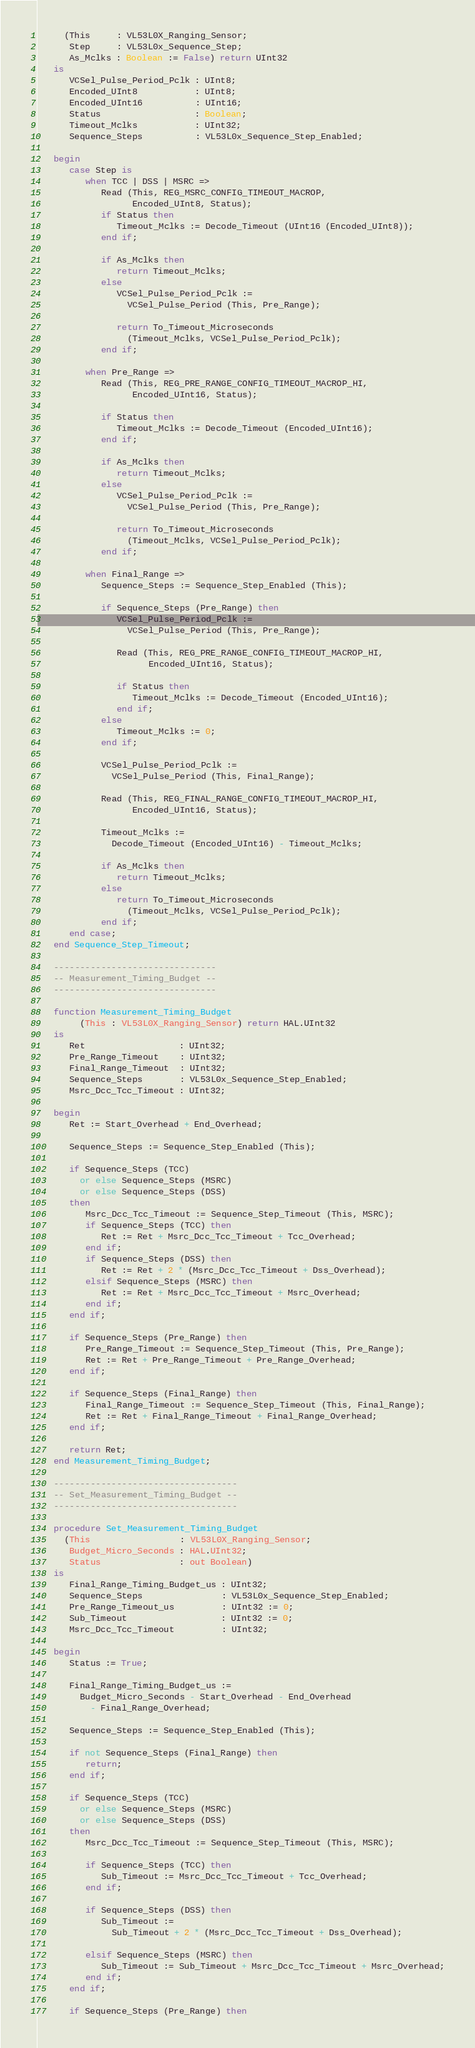<code> <loc_0><loc_0><loc_500><loc_500><_Ada_>     (This     : VL53L0X_Ranging_Sensor;
      Step     : VL53L0x_Sequence_Step;
      As_Mclks : Boolean := False) return UInt32
   is
      VCSel_Pulse_Period_Pclk : UInt8;
      Encoded_UInt8           : UInt8;
      Encoded_UInt16          : UInt16;
      Status                  : Boolean;
      Timeout_Mclks           : UInt32;
      Sequence_Steps          : VL53L0x_Sequence_Step_Enabled;

   begin
      case Step is
         when TCC | DSS | MSRC =>
            Read (This, REG_MSRC_CONFIG_TIMEOUT_MACROP,
                  Encoded_UInt8, Status);
            if Status then
               Timeout_Mclks := Decode_Timeout (UInt16 (Encoded_UInt8));
            end if;

            if As_Mclks then
               return Timeout_Mclks;
            else
               VCSel_Pulse_Period_Pclk :=
                 VCSel_Pulse_Period (This, Pre_Range);

               return To_Timeout_Microseconds
                 (Timeout_Mclks, VCSel_Pulse_Period_Pclk);
            end if;

         when Pre_Range =>
            Read (This, REG_PRE_RANGE_CONFIG_TIMEOUT_MACROP_HI,
                  Encoded_UInt16, Status);

            if Status then
               Timeout_Mclks := Decode_Timeout (Encoded_UInt16);
            end if;

            if As_Mclks then
               return Timeout_Mclks;
            else
               VCSel_Pulse_Period_Pclk :=
                 VCSel_Pulse_Period (This, Pre_Range);

               return To_Timeout_Microseconds
                 (Timeout_Mclks, VCSel_Pulse_Period_Pclk);
            end if;

         when Final_Range =>
            Sequence_Steps := Sequence_Step_Enabled (This);

            if Sequence_Steps (Pre_Range) then
               VCSel_Pulse_Period_Pclk :=
                 VCSel_Pulse_Period (This, Pre_Range);

               Read (This, REG_PRE_RANGE_CONFIG_TIMEOUT_MACROP_HI,
                     Encoded_UInt16, Status);

               if Status then
                  Timeout_Mclks := Decode_Timeout (Encoded_UInt16);
               end if;
            else
               Timeout_Mclks := 0;
            end if;

            VCSel_Pulse_Period_Pclk :=
              VCSel_Pulse_Period (This, Final_Range);

            Read (This, REG_FINAL_RANGE_CONFIG_TIMEOUT_MACROP_HI,
                  Encoded_UInt16, Status);

            Timeout_Mclks :=
              Decode_Timeout (Encoded_UInt16) - Timeout_Mclks;

            if As_Mclks then
               return Timeout_Mclks;
            else
               return To_Timeout_Microseconds
                 (Timeout_Mclks, VCSel_Pulse_Period_Pclk);
            end if;
      end case;
   end Sequence_Step_Timeout;

   -------------------------------
   -- Measurement_Timing_Budget --
   -------------------------------

   function Measurement_Timing_Budget
        (This : VL53L0X_Ranging_Sensor) return HAL.UInt32
   is
      Ret                  : UInt32;
      Pre_Range_Timeout    : UInt32;
      Final_Range_Timeout  : UInt32;
      Sequence_Steps       : VL53L0x_Sequence_Step_Enabled;
      Msrc_Dcc_Tcc_Timeout : UInt32;

   begin
      Ret := Start_Overhead + End_Overhead;

      Sequence_Steps := Sequence_Step_Enabled (This);

      if Sequence_Steps (TCC)
        or else Sequence_Steps (MSRC)
        or else Sequence_Steps (DSS)
      then
         Msrc_Dcc_Tcc_Timeout := Sequence_Step_Timeout (This, MSRC);
         if Sequence_Steps (TCC) then
            Ret := Ret + Msrc_Dcc_Tcc_Timeout + Tcc_Overhead;
         end if;
         if Sequence_Steps (DSS) then
            Ret := Ret + 2 * (Msrc_Dcc_Tcc_Timeout + Dss_Overhead);
         elsif Sequence_Steps (MSRC) then
            Ret := Ret + Msrc_Dcc_Tcc_Timeout + Msrc_Overhead;
         end if;
      end if;

      if Sequence_Steps (Pre_Range) then
         Pre_Range_Timeout := Sequence_Step_Timeout (This, Pre_Range);
         Ret := Ret + Pre_Range_Timeout + Pre_Range_Overhead;
      end if;

      if Sequence_Steps (Final_Range) then
         Final_Range_Timeout := Sequence_Step_Timeout (This, Final_Range);
         Ret := Ret + Final_Range_Timeout + Final_Range_Overhead;
      end if;

      return Ret;
   end Measurement_Timing_Budget;

   -----------------------------------
   -- Set_Measurement_Timing_Budget --
   -----------------------------------

   procedure Set_Measurement_Timing_Budget
     (This                 : VL53L0X_Ranging_Sensor;
      Budget_Micro_Seconds : HAL.UInt32;
      Status               : out Boolean)
   is
      Final_Range_Timing_Budget_us : UInt32;
      Sequence_Steps               : VL53L0x_Sequence_Step_Enabled;
      Pre_Range_Timeout_us         : UInt32 := 0;
      Sub_Timeout                  : UInt32 := 0;
      Msrc_Dcc_Tcc_Timeout         : UInt32;

   begin
      Status := True;

      Final_Range_Timing_Budget_us :=
        Budget_Micro_Seconds - Start_Overhead - End_Overhead
          - Final_Range_Overhead;

      Sequence_Steps := Sequence_Step_Enabled (This);

      if not Sequence_Steps (Final_Range) then
         return;
      end if;

      if Sequence_Steps (TCC)
        or else Sequence_Steps (MSRC)
        or else Sequence_Steps (DSS)
      then
         Msrc_Dcc_Tcc_Timeout := Sequence_Step_Timeout (This, MSRC);

         if Sequence_Steps (TCC) then
            Sub_Timeout := Msrc_Dcc_Tcc_Timeout + Tcc_Overhead;
         end if;

         if Sequence_Steps (DSS) then
            Sub_Timeout :=
              Sub_Timeout + 2 * (Msrc_Dcc_Tcc_Timeout + Dss_Overhead);

         elsif Sequence_Steps (MSRC) then
            Sub_Timeout := Sub_Timeout + Msrc_Dcc_Tcc_Timeout + Msrc_Overhead;
         end if;
      end if;

      if Sequence_Steps (Pre_Range) then</code> 